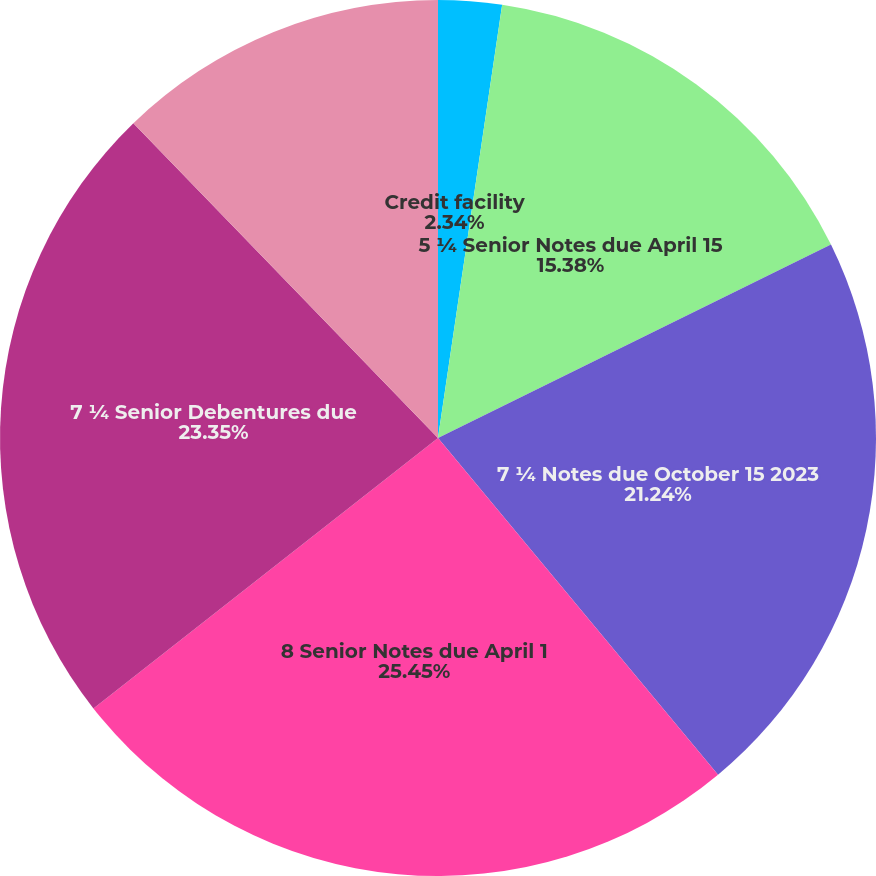<chart> <loc_0><loc_0><loc_500><loc_500><pie_chart><fcel>Credit facility<fcel>5 ¼ Senior Notes due April 15<fcel>7 ¼ Notes due October 15 2023<fcel>8 Senior Notes due April 1<fcel>7 ¼ Senior Debentures due<fcel>Installment payments - current<nl><fcel>2.34%<fcel>15.38%<fcel>21.24%<fcel>25.45%<fcel>23.35%<fcel>12.24%<nl></chart> 